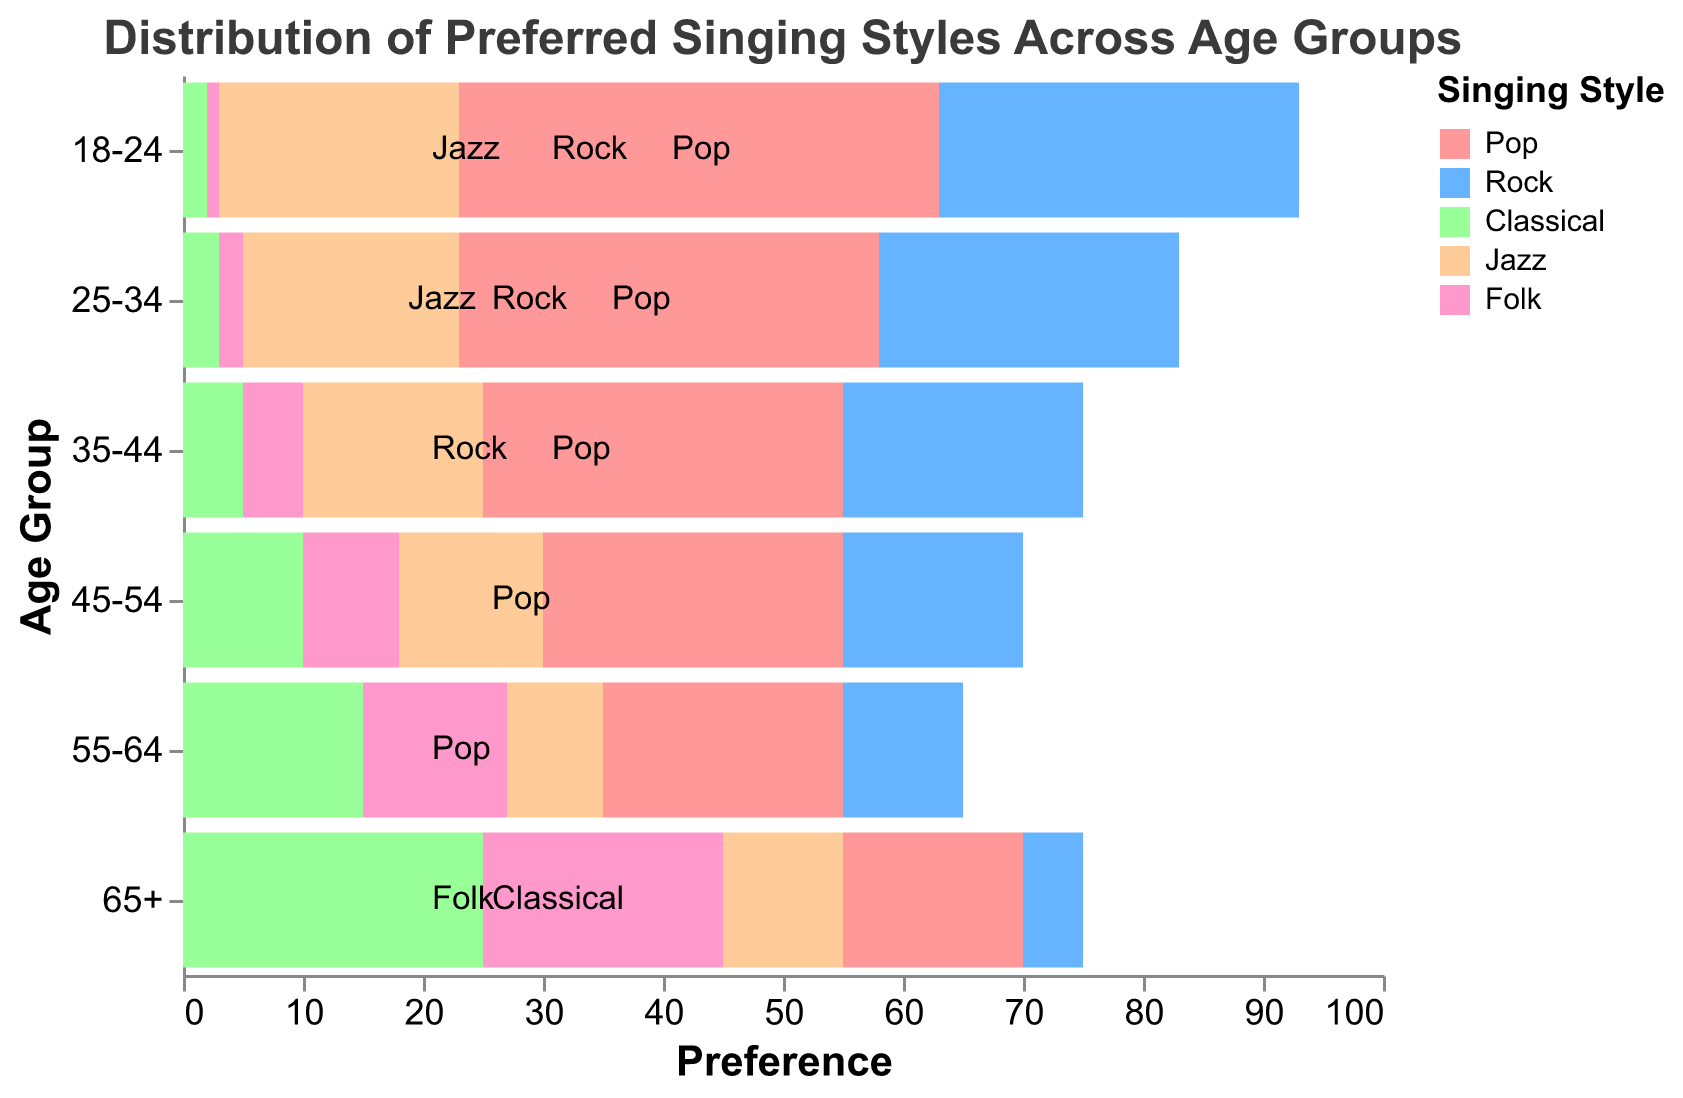What is the title of the figure? The title of the figure is displayed at the top and reads "Distribution of Preferred Singing Styles Across Age Groups."
Answer: Distribution of Preferred Singing Styles Across Age Groups Which age group has the highest preference for Classical music? The age group with the highest preference for Classical can be identified by observing the largest bar in the Classical category. The "65+" age group has the highest value (25) for Classical music.
Answer: 65+ How does the preference for Rock compare between the 18-24 and 45-54 age groups? The Rock preference for the 18-24 age group is represented by a positive bar reaching 30, while for the 45-54 age group, it reaches 15. 30 is greater than 15, so the 18-24 age group has a higher preference for Rock than the 45-54 age group.
Answer: 18-24 Which singing style has the least popularity in the 25-34 age group? To find the least popular style, we compare the values for each style within the 25-34 age group. The values are Pop: -35, Rock: 25, Classical: 3, Jazz: -18, and Folk: 2. The least (most negative) value is for Pop.
Answer: Pop How many age groups have a negative preference for Pop music? Counting the age groups that have a negative value in the Pop column: all age groups (65+, 55-64, 45-54, 35-44, 25-34, 18-24) have negative preferences for Pop. So, there are 6 age groups.
Answer: 6 